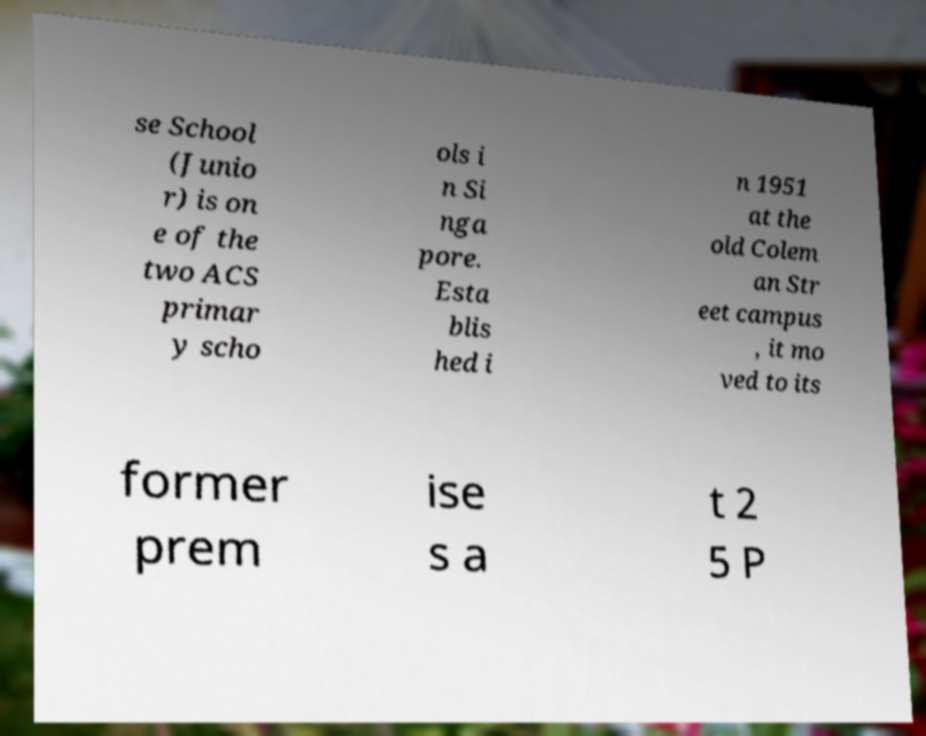Could you assist in decoding the text presented in this image and type it out clearly? se School (Junio r) is on e of the two ACS primar y scho ols i n Si nga pore. Esta blis hed i n 1951 at the old Colem an Str eet campus , it mo ved to its former prem ise s a t 2 5 P 